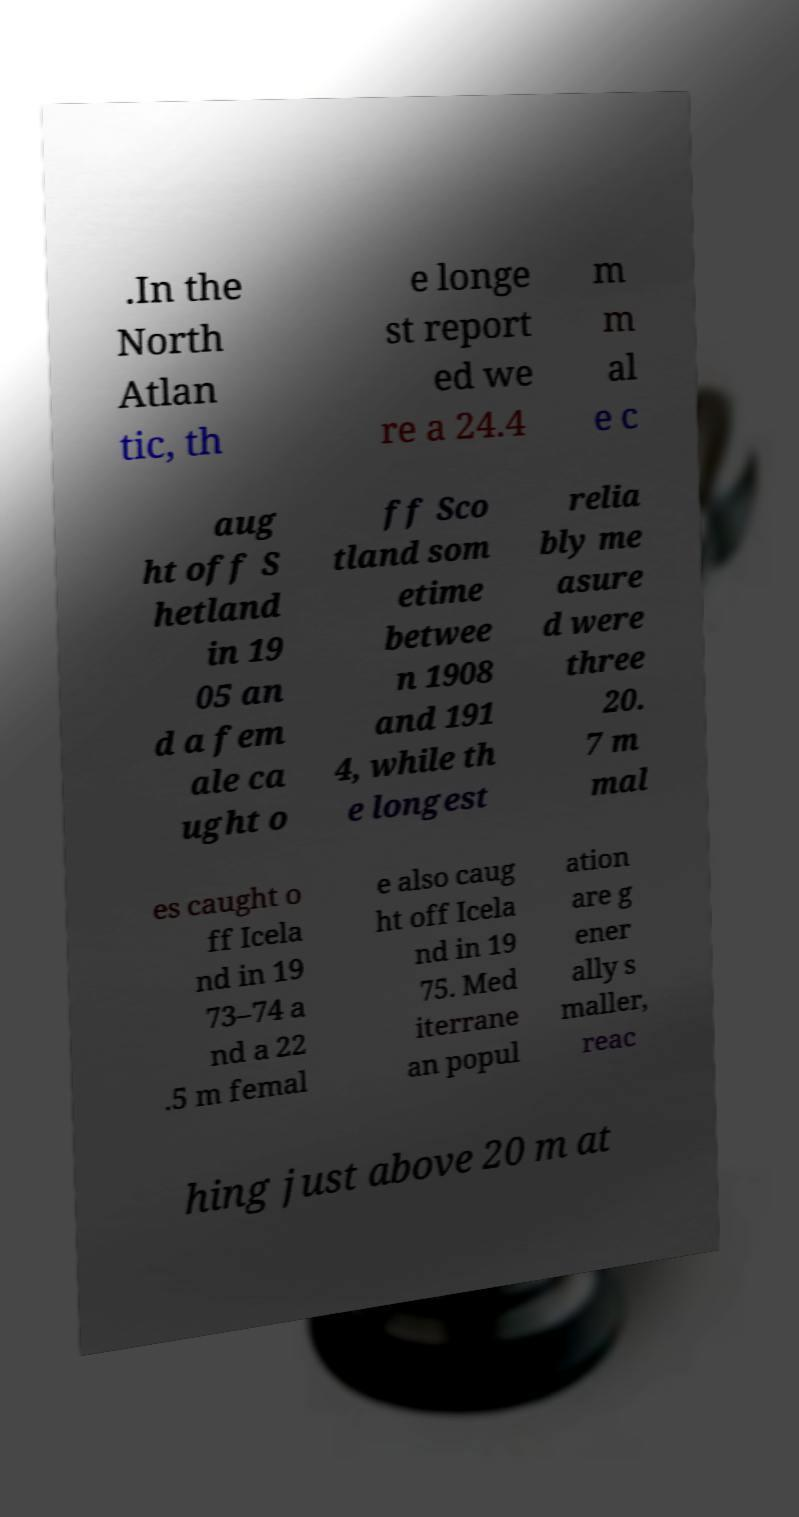I need the written content from this picture converted into text. Can you do that? .In the North Atlan tic, th e longe st report ed we re a 24.4 m m al e c aug ht off S hetland in 19 05 an d a fem ale ca ught o ff Sco tland som etime betwee n 1908 and 191 4, while th e longest relia bly me asure d were three 20. 7 m mal es caught o ff Icela nd in 19 73–74 a nd a 22 .5 m femal e also caug ht off Icela nd in 19 75. Med iterrane an popul ation are g ener ally s maller, reac hing just above 20 m at 